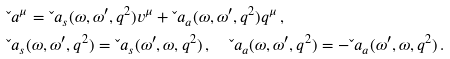Convert formula to latex. <formula><loc_0><loc_0><loc_500><loc_500>& \L a ^ { \mu } = \L a _ { s } ( \omega , \omega ^ { \prime } , q ^ { 2 } ) v ^ { \mu } + \L a _ { a } ( \omega , \omega ^ { \prime } , q ^ { 2 } ) q ^ { \mu } \, , \\ & \L a _ { s } ( \omega , \omega ^ { \prime } , q ^ { 2 } ) = \L a _ { s } ( \omega ^ { \prime } , \omega , q ^ { 2 } ) \, , \quad \L a _ { a } ( \omega , \omega ^ { \prime } , q ^ { 2 } ) = - \L a _ { a } ( \omega ^ { \prime } , \omega , q ^ { 2 } ) \, .</formula> 